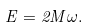<formula> <loc_0><loc_0><loc_500><loc_500>E = 2 M \omega .</formula> 